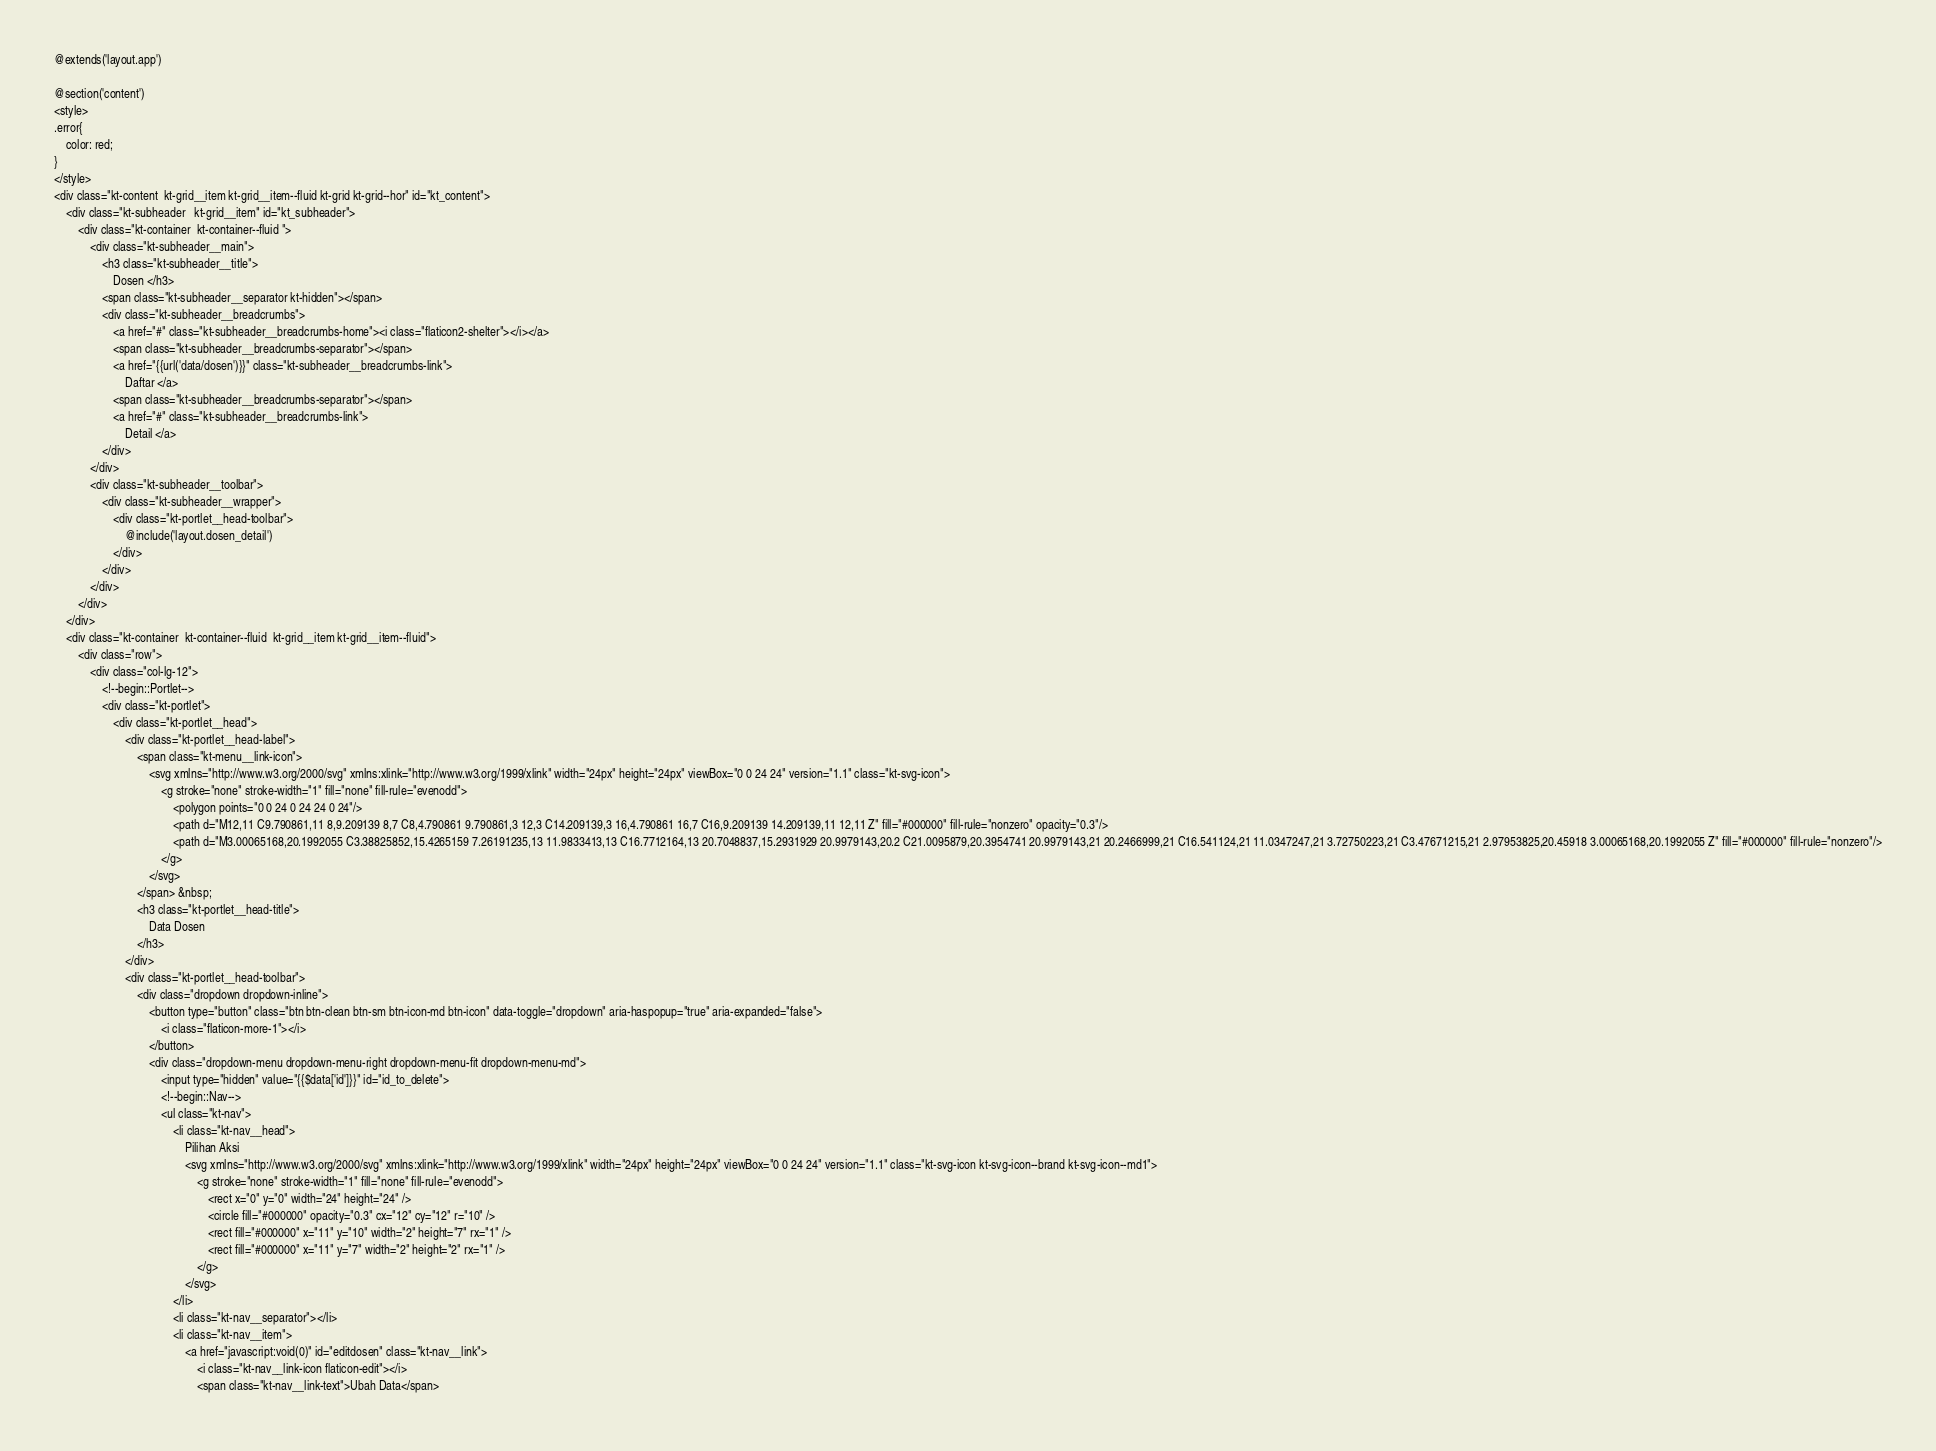Convert code to text. <code><loc_0><loc_0><loc_500><loc_500><_PHP_>@extends('layout.app')

@section('content')
<style>
.error{
    color: red;
}
</style>
<div class="kt-content  kt-grid__item kt-grid__item--fluid kt-grid kt-grid--hor" id="kt_content">
    <div class="kt-subheader   kt-grid__item" id="kt_subheader">
        <div class="kt-container  kt-container--fluid ">
            <div class="kt-subheader__main">
                <h3 class="kt-subheader__title">
                    Dosen </h3>
                <span class="kt-subheader__separator kt-hidden"></span>
                <div class="kt-subheader__breadcrumbs">
                    <a href="#" class="kt-subheader__breadcrumbs-home"><i class="flaticon2-shelter"></i></a>
                    <span class="kt-subheader__breadcrumbs-separator"></span>
                    <a href="{{url('data/dosen')}}" class="kt-subheader__breadcrumbs-link">
                        Daftar </a>
                    <span class="kt-subheader__breadcrumbs-separator"></span>
                    <a href="#" class="kt-subheader__breadcrumbs-link">
                        Detail </a>
                </div>
            </div>
            <div class="kt-subheader__toolbar">
                <div class="kt-subheader__wrapper">
                    <div class="kt-portlet__head-toolbar">
                        @include('layout.dosen_detail')
                    </div>
                </div>
            </div>
        </div>
    </div>
    <div class="kt-container  kt-container--fluid  kt-grid__item kt-grid__item--fluid">
        <div class="row">
            <div class="col-lg-12">
                <!--begin::Portlet-->
                <div class="kt-portlet">
                    <div class="kt-portlet__head">
                        <div class="kt-portlet__head-label">
                            <span class="kt-menu__link-icon">
                                <svg xmlns="http://www.w3.org/2000/svg" xmlns:xlink="http://www.w3.org/1999/xlink" width="24px" height="24px" viewBox="0 0 24 24" version="1.1" class="kt-svg-icon">
                                    <g stroke="none" stroke-width="1" fill="none" fill-rule="evenodd">
                                        <polygon points="0 0 24 0 24 24 0 24"/>
                                        <path d="M12,11 C9.790861,11 8,9.209139 8,7 C8,4.790861 9.790861,3 12,3 C14.209139,3 16,4.790861 16,7 C16,9.209139 14.209139,11 12,11 Z" fill="#000000" fill-rule="nonzero" opacity="0.3"/>
                                        <path d="M3.00065168,20.1992055 C3.38825852,15.4265159 7.26191235,13 11.9833413,13 C16.7712164,13 20.7048837,15.2931929 20.9979143,20.2 C21.0095879,20.3954741 20.9979143,21 20.2466999,21 C16.541124,21 11.0347247,21 3.72750223,21 C3.47671215,21 2.97953825,20.45918 3.00065168,20.1992055 Z" fill="#000000" fill-rule="nonzero"/>
                                    </g>
                                </svg>
                            </span> &nbsp;
                            <h3 class="kt-portlet__head-title">
                                Data Dosen
                            </h3>
                        </div>
                        <div class="kt-portlet__head-toolbar">
                            <div class="dropdown dropdown-inline">
                                <button type="button" class="btn btn-clean btn-sm btn-icon-md btn-icon" data-toggle="dropdown" aria-haspopup="true" aria-expanded="false">
                                    <i class="flaticon-more-1"></i>
                                </button>
                                <div class="dropdown-menu dropdown-menu-right dropdown-menu-fit dropdown-menu-md">
                                    <input type="hidden" value="{{$data['id']}}" id="id_to_delete">
                                    <!--begin::Nav-->
                                    <ul class="kt-nav">
                                        <li class="kt-nav__head">
                                            Pilihan Aksi
                                            <svg xmlns="http://www.w3.org/2000/svg" xmlns:xlink="http://www.w3.org/1999/xlink" width="24px" height="24px" viewBox="0 0 24 24" version="1.1" class="kt-svg-icon kt-svg-icon--brand kt-svg-icon--md1">
                                                <g stroke="none" stroke-width="1" fill="none" fill-rule="evenodd">
                                                    <rect x="0" y="0" width="24" height="24" />
                                                    <circle fill="#000000" opacity="0.3" cx="12" cy="12" r="10" />
                                                    <rect fill="#000000" x="11" y="10" width="2" height="7" rx="1" />
                                                    <rect fill="#000000" x="11" y="7" width="2" height="2" rx="1" />
                                                </g>
                                            </svg>
                                        </li>
                                        <li class="kt-nav__separator"></li>
                                        <li class="kt-nav__item">
                                            <a href="javascript:void(0)" id="editdosen" class="kt-nav__link">
                                                <i class="kt-nav__link-icon flaticon-edit"></i>
                                                <span class="kt-nav__link-text">Ubah Data</span></code> 